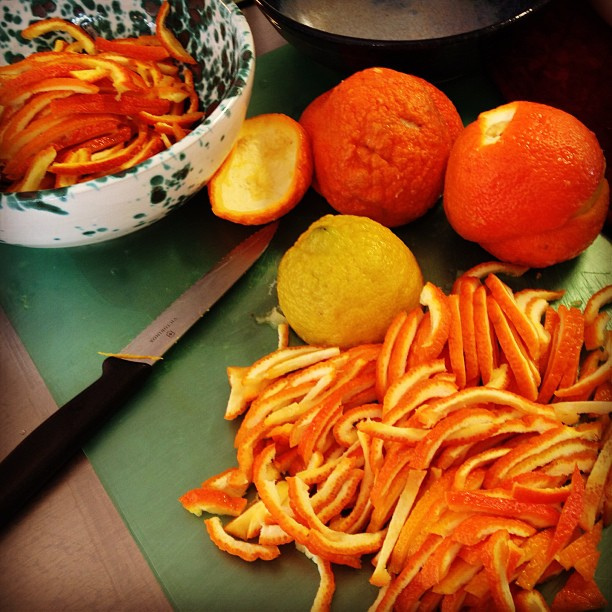<image>Which fruit is for sale? It is not clear which fruit is for sale. It could be oranges or there might be no fruit for sale. Which fruit is for sale? The fruit for sale is orange. 